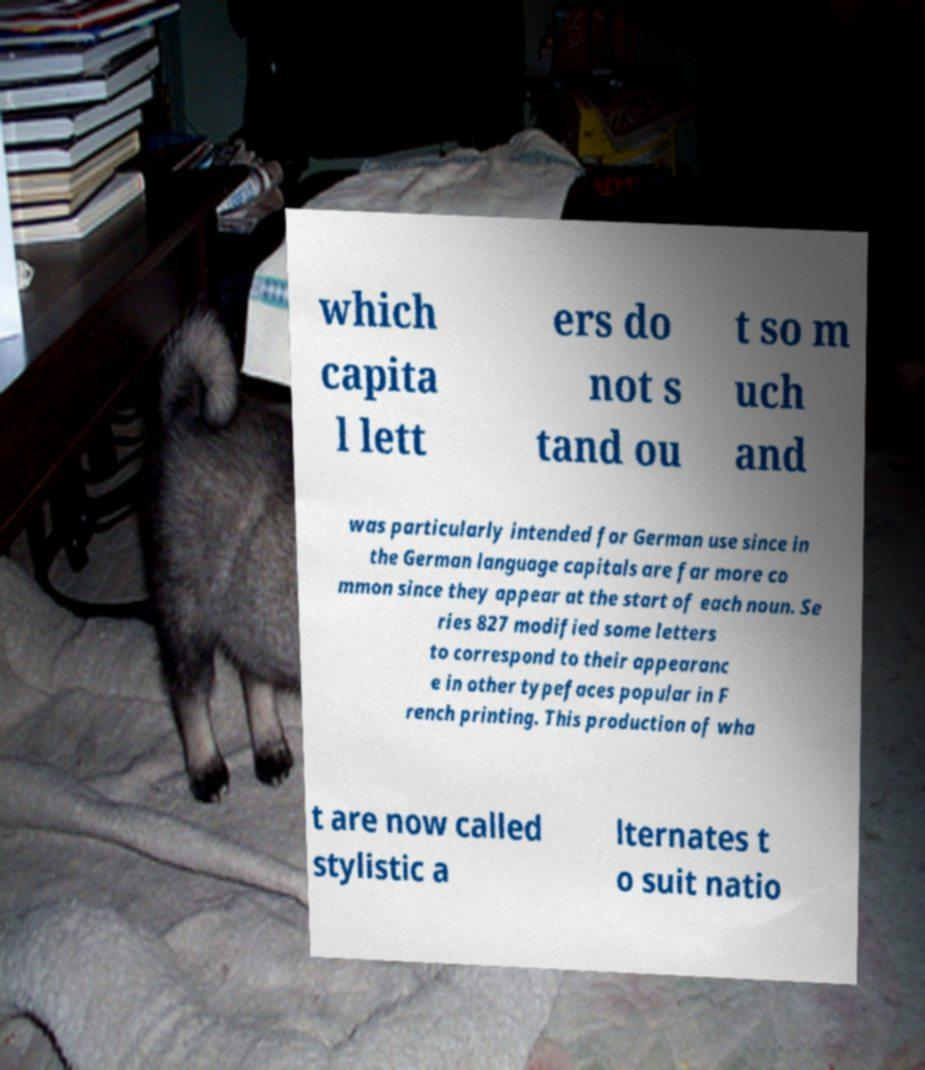Could you extract and type out the text from this image? which capita l lett ers do not s tand ou t so m uch and was particularly intended for German use since in the German language capitals are far more co mmon since they appear at the start of each noun. Se ries 827 modified some letters to correspond to their appearanc e in other typefaces popular in F rench printing. This production of wha t are now called stylistic a lternates t o suit natio 